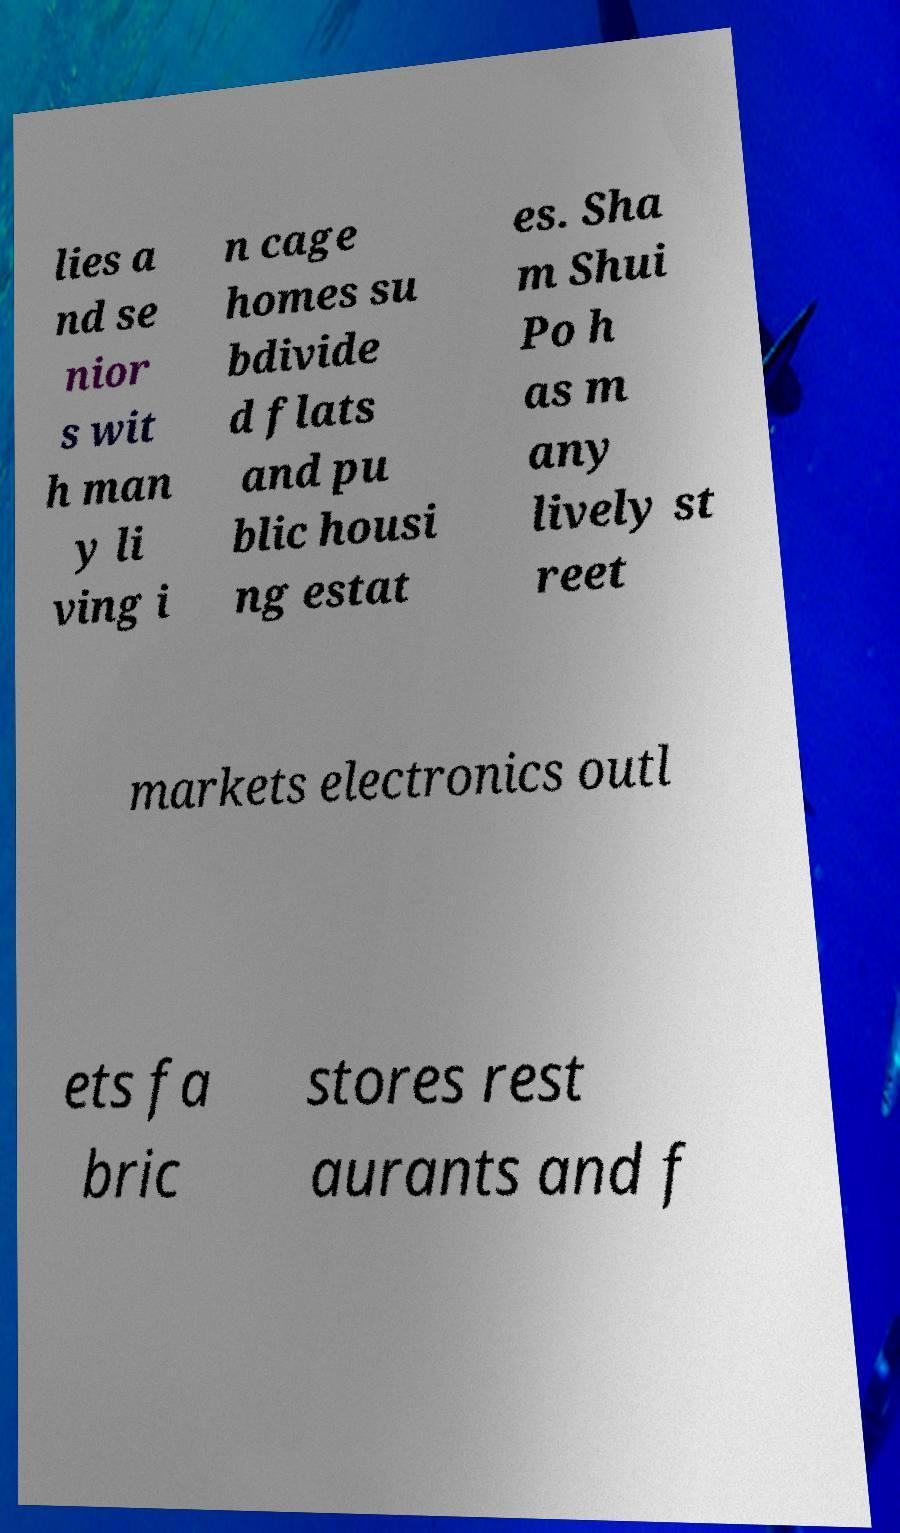Please identify and transcribe the text found in this image. lies a nd se nior s wit h man y li ving i n cage homes su bdivide d flats and pu blic housi ng estat es. Sha m Shui Po h as m any lively st reet markets electronics outl ets fa bric stores rest aurants and f 